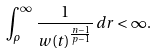<formula> <loc_0><loc_0><loc_500><loc_500>\int _ { \rho } ^ { \infty } \, \frac { 1 } { w ( t ) ^ { \frac { n - 1 } { p - 1 } } } \, d r < \infty .</formula> 